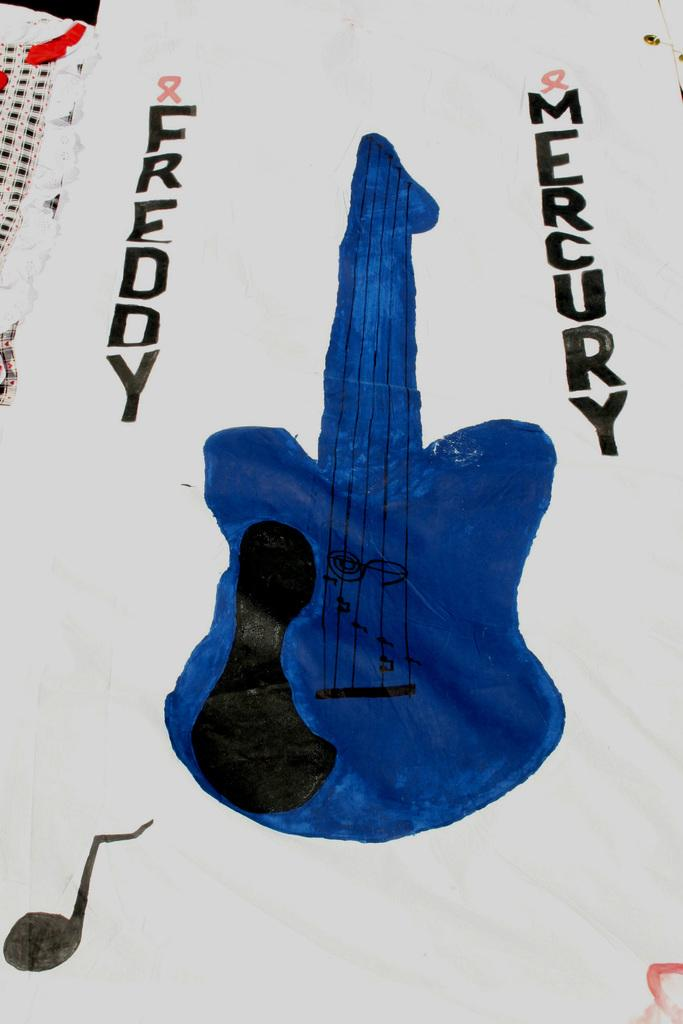What is the main subject of the painting in the image? The painting depicts a guitar. What color is the guitar in the painting? The guitar is in blue color. Is there a patch on the guitar in the painting? There is no mention of a patch on the guitar in the painting, so we cannot determine its presence from the image. 